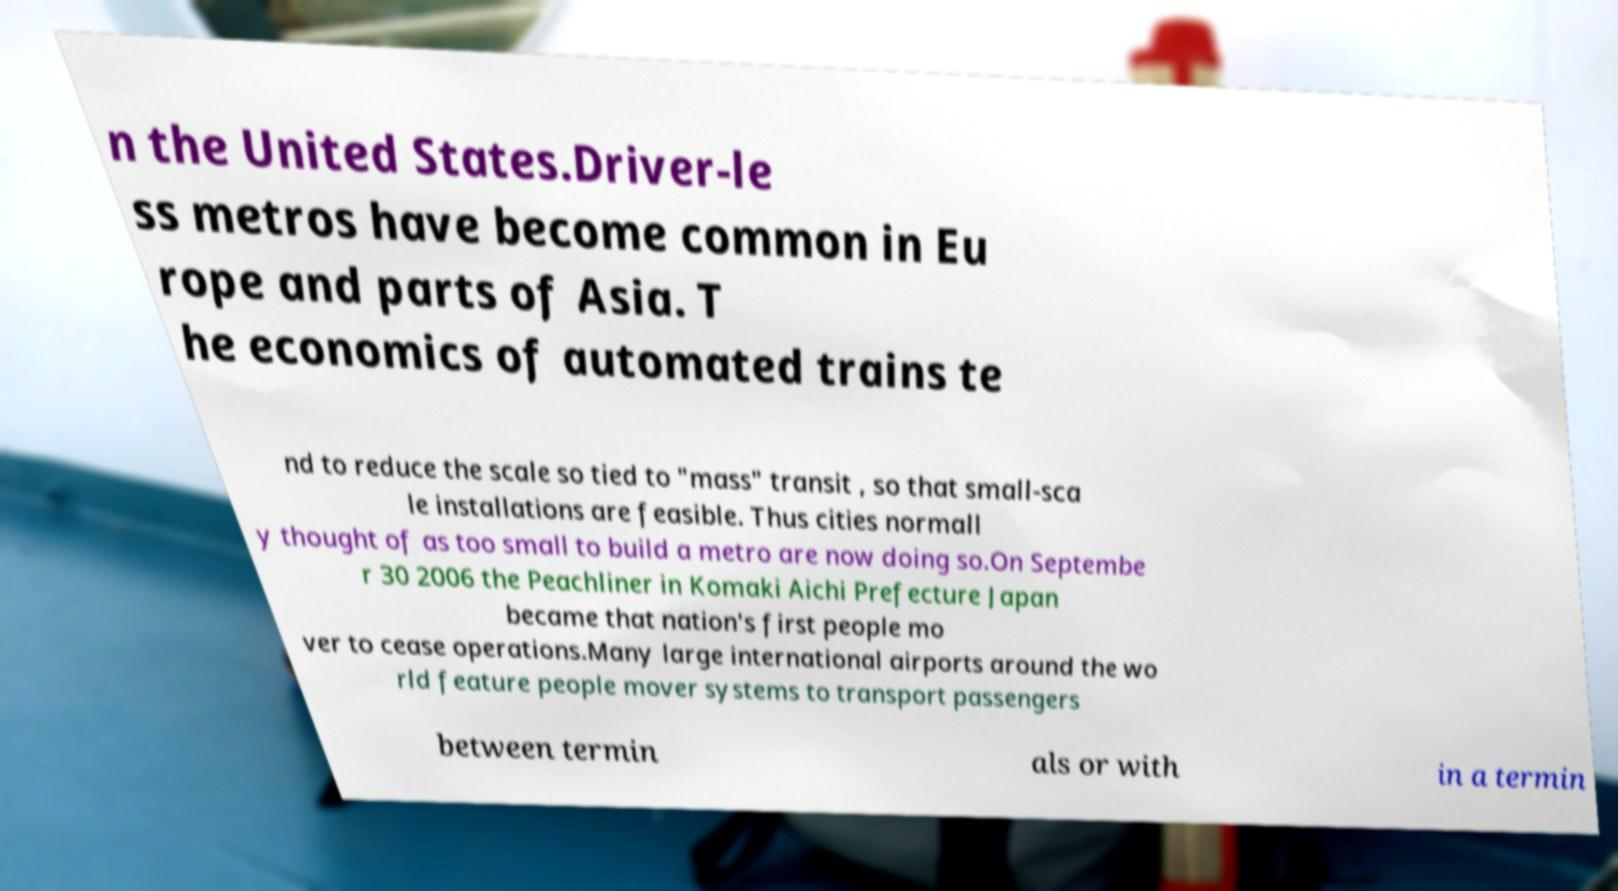For documentation purposes, I need the text within this image transcribed. Could you provide that? n the United States.Driver-le ss metros have become common in Eu rope and parts of Asia. T he economics of automated trains te nd to reduce the scale so tied to "mass" transit , so that small-sca le installations are feasible. Thus cities normall y thought of as too small to build a metro are now doing so.On Septembe r 30 2006 the Peachliner in Komaki Aichi Prefecture Japan became that nation's first people mo ver to cease operations.Many large international airports around the wo rld feature people mover systems to transport passengers between termin als or with in a termin 